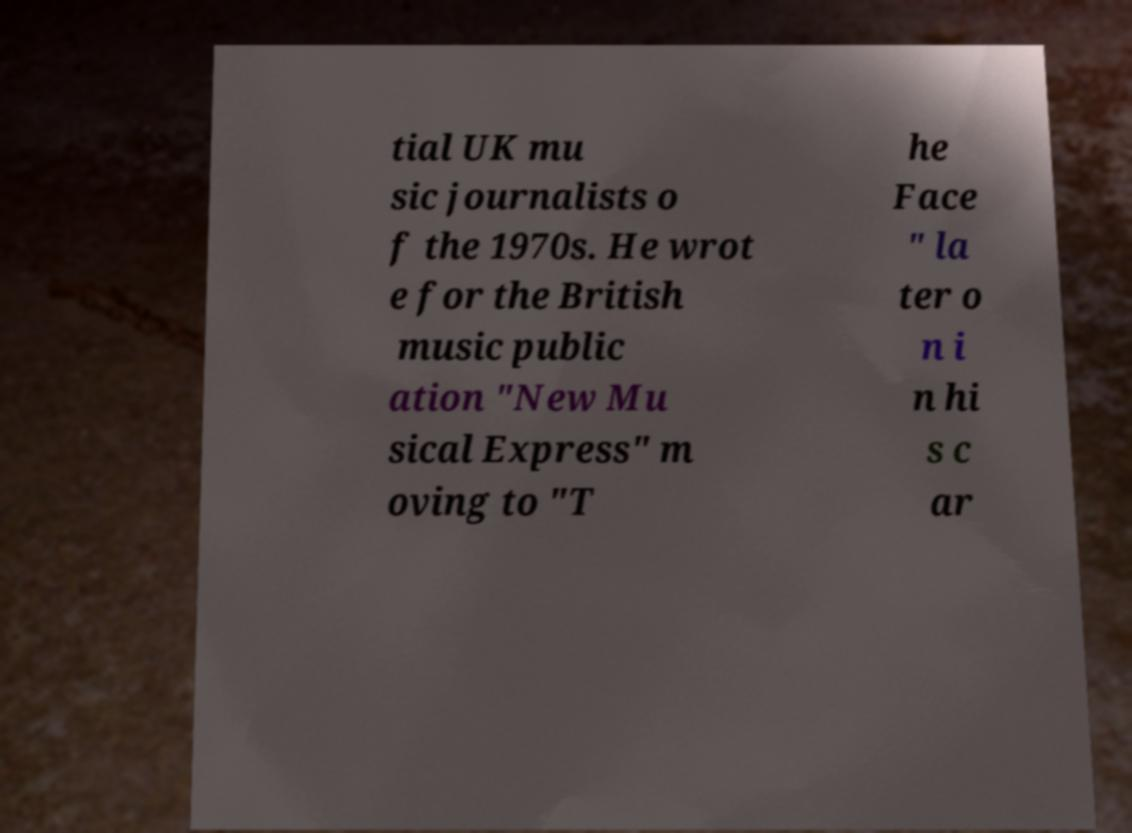Please identify and transcribe the text found in this image. tial UK mu sic journalists o f the 1970s. He wrot e for the British music public ation "New Mu sical Express" m oving to "T he Face " la ter o n i n hi s c ar 